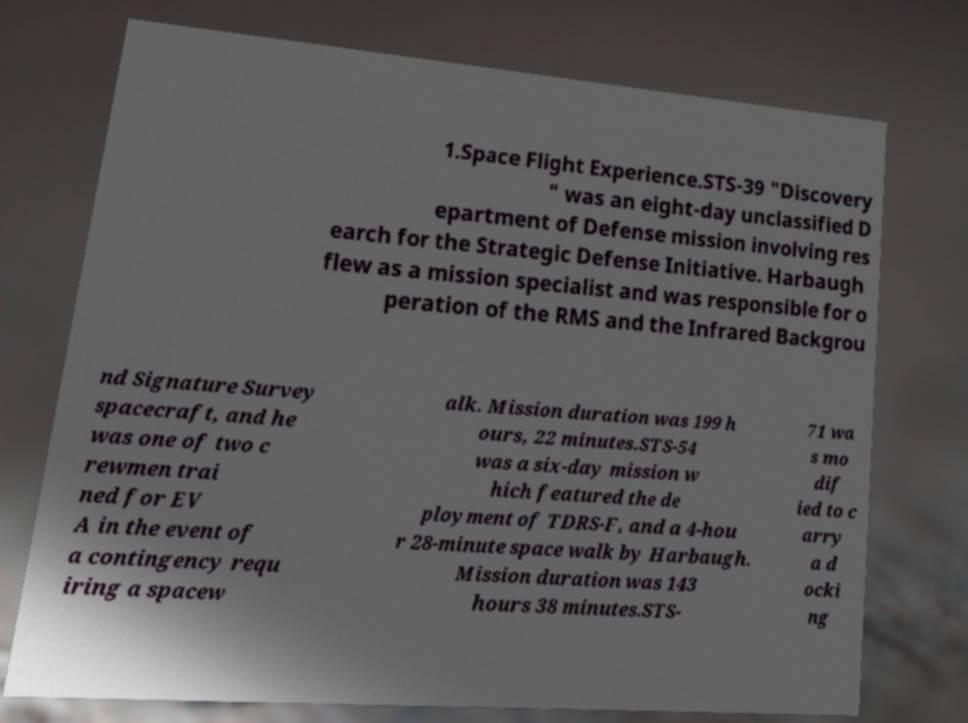What messages or text are displayed in this image? I need them in a readable, typed format. 1.Space Flight Experience.STS-39 "Discovery " was an eight-day unclassified D epartment of Defense mission involving res earch for the Strategic Defense Initiative. Harbaugh flew as a mission specialist and was responsible for o peration of the RMS and the Infrared Backgrou nd Signature Survey spacecraft, and he was one of two c rewmen trai ned for EV A in the event of a contingency requ iring a spacew alk. Mission duration was 199 h ours, 22 minutes.STS-54 was a six-day mission w hich featured the de ployment of TDRS-F, and a 4-hou r 28-minute space walk by Harbaugh. Mission duration was 143 hours 38 minutes.STS- 71 wa s mo dif ied to c arry a d ocki ng 